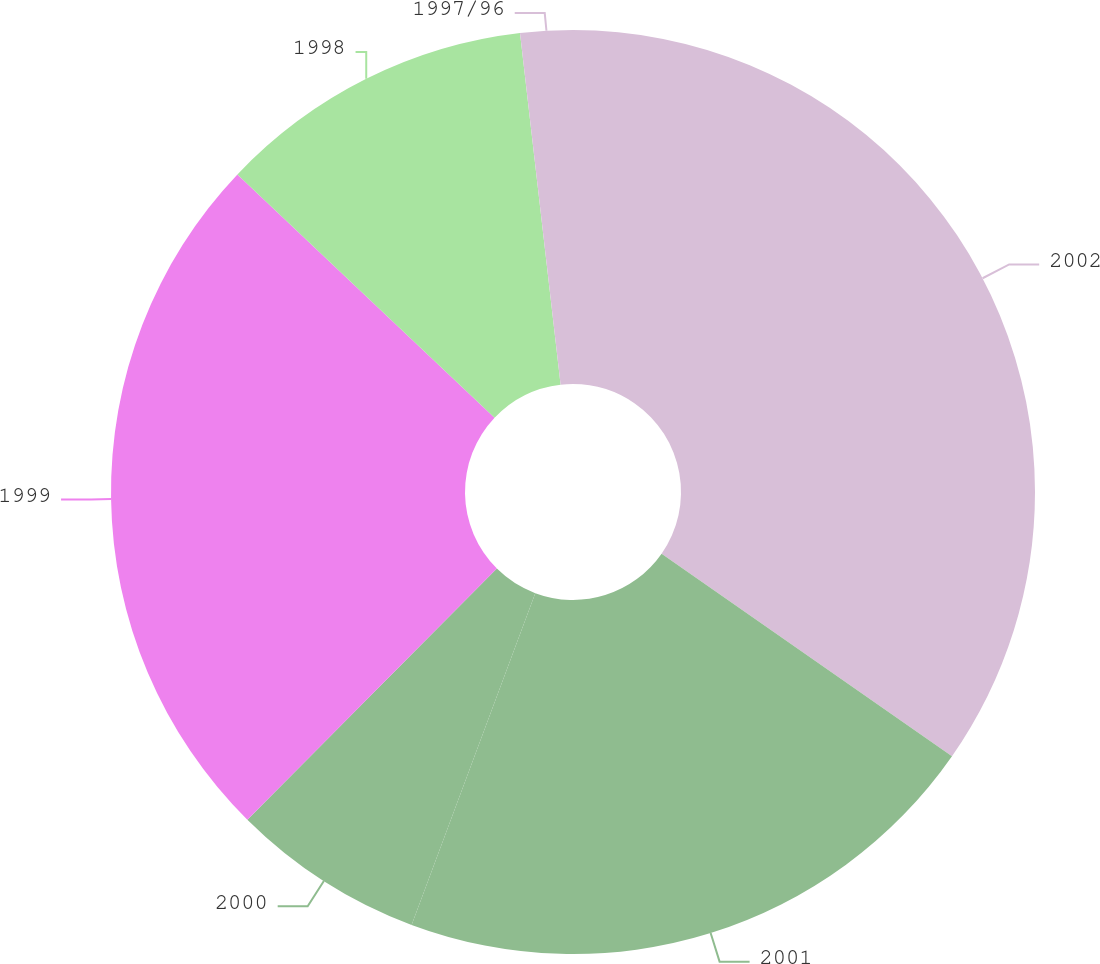Convert chart to OTSL. <chart><loc_0><loc_0><loc_500><loc_500><pie_chart><fcel>2002<fcel>2001<fcel>2000<fcel>1999<fcel>1998<fcel>1997/96<nl><fcel>34.69%<fcel>20.99%<fcel>6.77%<fcel>24.61%<fcel>11.11%<fcel>1.83%<nl></chart> 